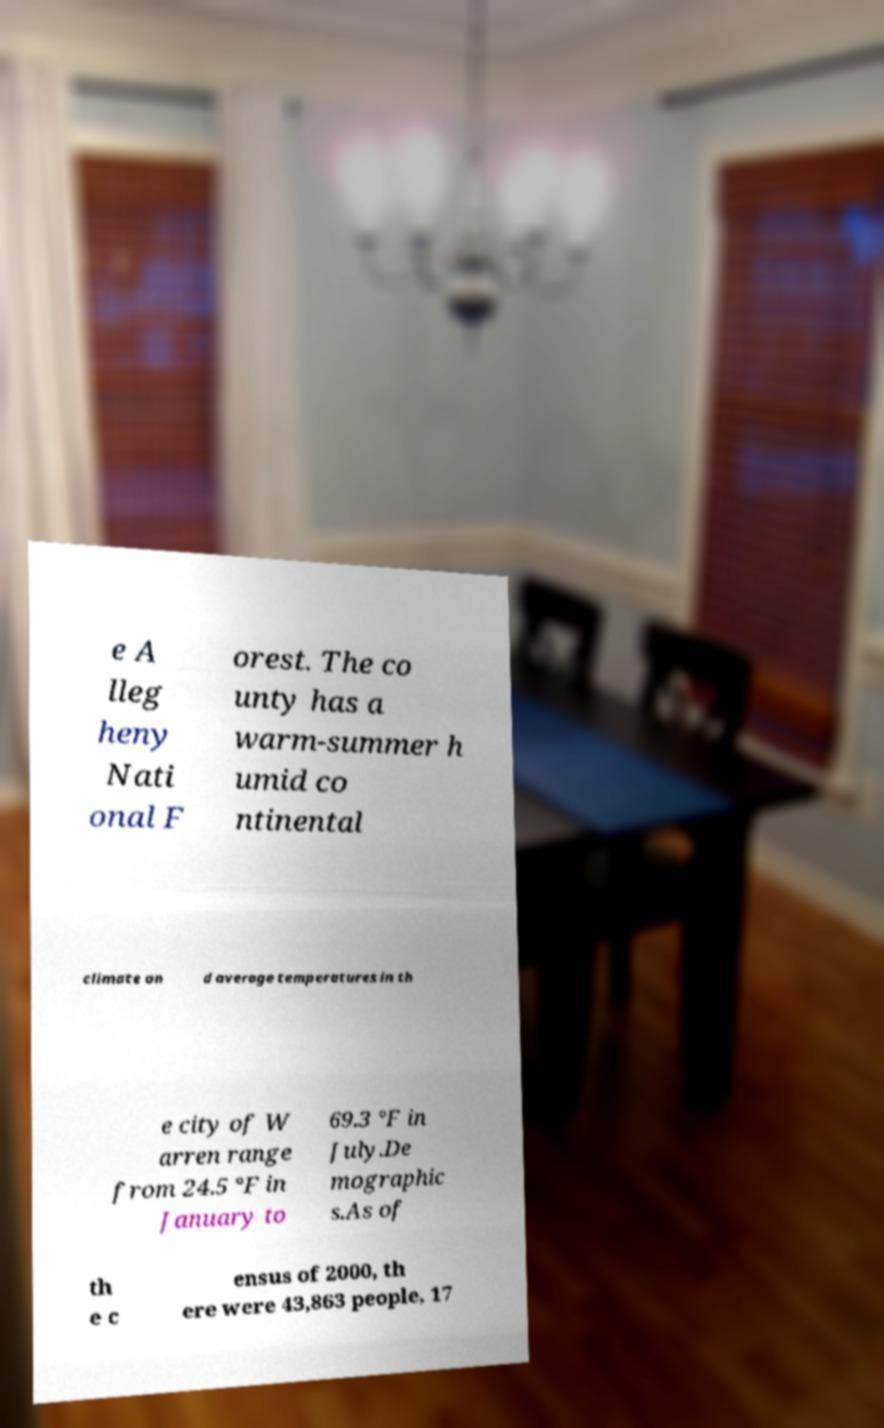Please identify and transcribe the text found in this image. e A lleg heny Nati onal F orest. The co unty has a warm-summer h umid co ntinental climate an d average temperatures in th e city of W arren range from 24.5 °F in January to 69.3 °F in July.De mographic s.As of th e c ensus of 2000, th ere were 43,863 people, 17 